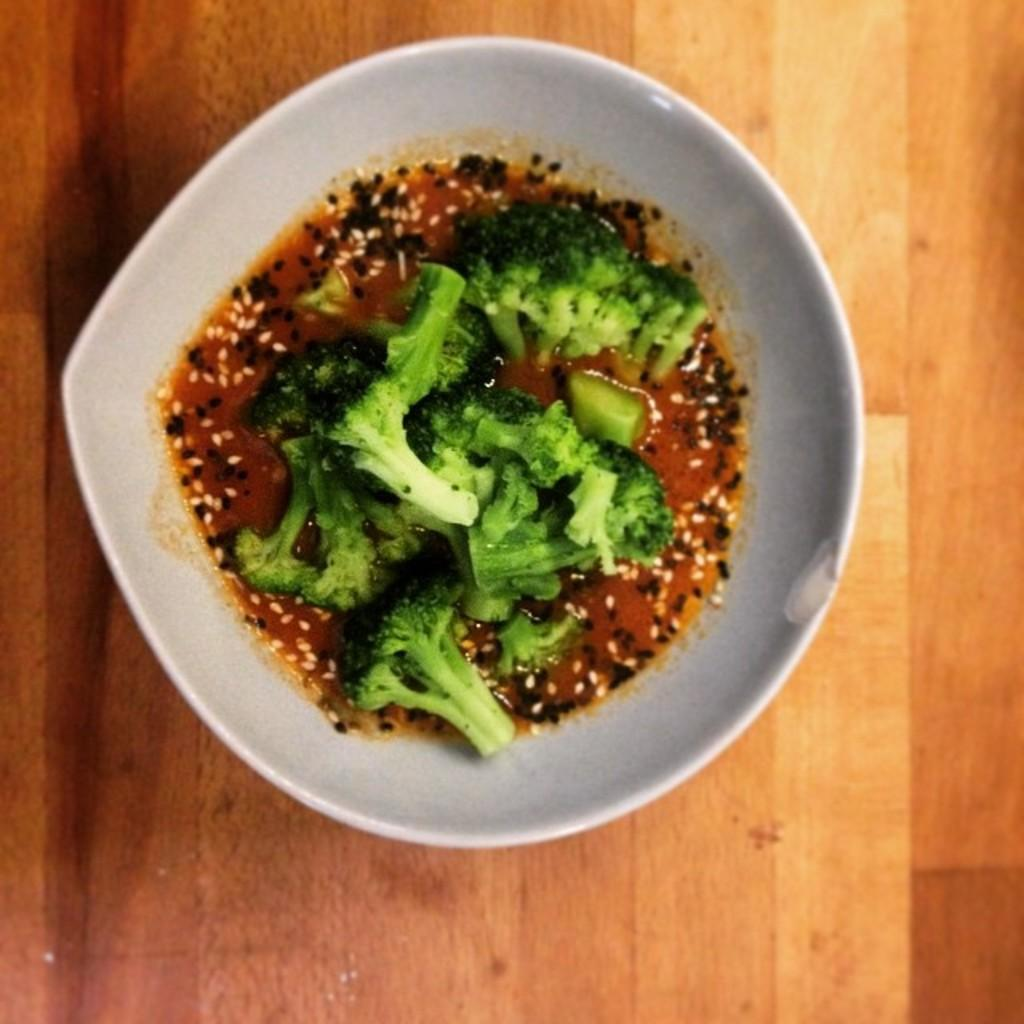What is in the bowl that is visible in the image? There is food in a bowl in the image. Where is the bowl located in the image? The bowl is on a platform. What type of toothpaste is used to clean the cub in the image? There is no toothpaste or cub present in the image. 